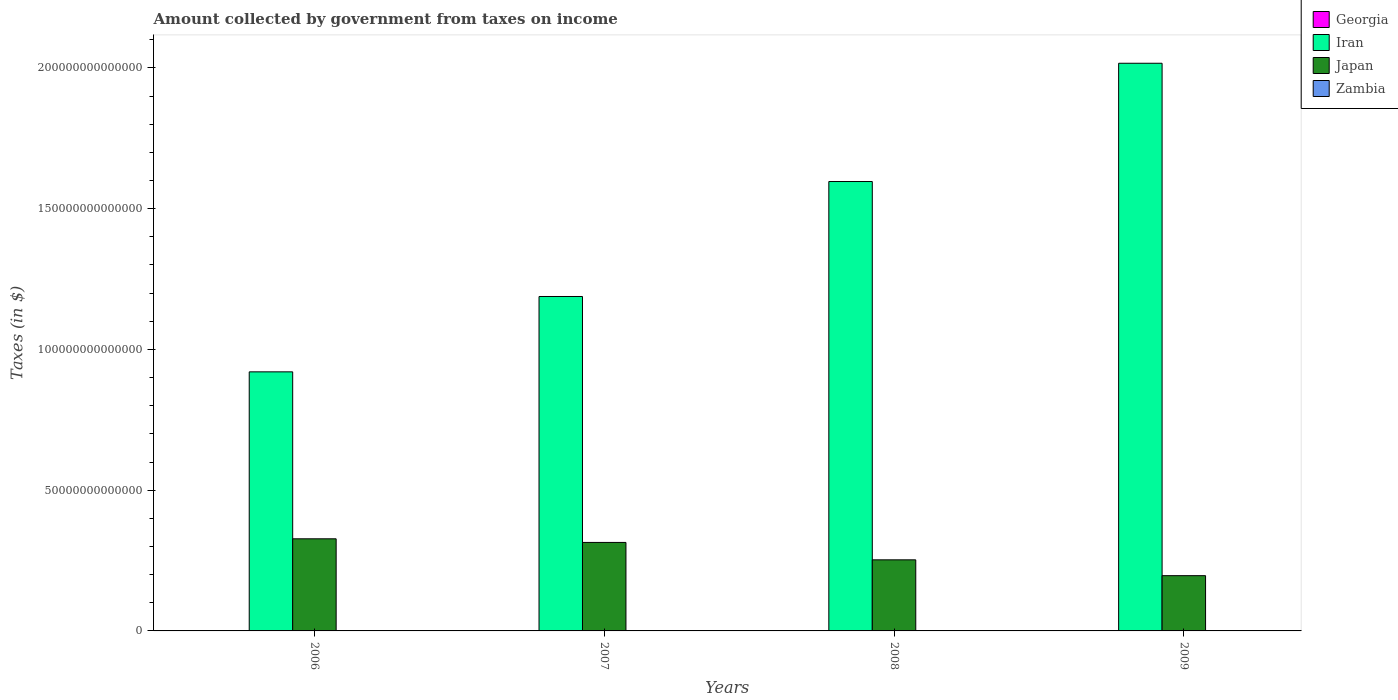Are the number of bars on each tick of the X-axis equal?
Offer a terse response. Yes. How many bars are there on the 1st tick from the left?
Your answer should be compact. 4. How many bars are there on the 1st tick from the right?
Your response must be concise. 4. What is the amount collected by government from taxes on income in Japan in 2008?
Your answer should be very brief. 2.53e+13. Across all years, what is the maximum amount collected by government from taxes on income in Japan?
Ensure brevity in your answer.  3.27e+13. Across all years, what is the minimum amount collected by government from taxes on income in Iran?
Ensure brevity in your answer.  9.20e+13. In which year was the amount collected by government from taxes on income in Georgia maximum?
Make the answer very short. 2008. In which year was the amount collected by government from taxes on income in Georgia minimum?
Your response must be concise. 2006. What is the total amount collected by government from taxes on income in Zambia in the graph?
Ensure brevity in your answer.  1.52e+1. What is the difference between the amount collected by government from taxes on income in Iran in 2006 and that in 2009?
Provide a succinct answer. -1.10e+14. What is the difference between the amount collected by government from taxes on income in Georgia in 2008 and the amount collected by government from taxes on income in Japan in 2009?
Ensure brevity in your answer.  -1.96e+13. What is the average amount collected by government from taxes on income in Iran per year?
Offer a terse response. 1.43e+14. In the year 2006, what is the difference between the amount collected by government from taxes on income in Iran and amount collected by government from taxes on income in Zambia?
Your answer should be compact. 9.20e+13. In how many years, is the amount collected by government from taxes on income in Iran greater than 130000000000000 $?
Keep it short and to the point. 2. What is the ratio of the amount collected by government from taxes on income in Japan in 2008 to that in 2009?
Your response must be concise. 1.29. Is the amount collected by government from taxes on income in Japan in 2007 less than that in 2009?
Your response must be concise. No. Is the difference between the amount collected by government from taxes on income in Iran in 2006 and 2008 greater than the difference between the amount collected by government from taxes on income in Zambia in 2006 and 2008?
Keep it short and to the point. No. What is the difference between the highest and the second highest amount collected by government from taxes on income in Georgia?
Provide a succinct answer. 2.40e+08. What is the difference between the highest and the lowest amount collected by government from taxes on income in Zambia?
Make the answer very short. 1.91e+09. In how many years, is the amount collected by government from taxes on income in Japan greater than the average amount collected by government from taxes on income in Japan taken over all years?
Your answer should be compact. 2. What does the 1st bar from the left in 2006 represents?
Offer a terse response. Georgia. What does the 3rd bar from the right in 2009 represents?
Provide a short and direct response. Iran. How many bars are there?
Give a very brief answer. 16. Are all the bars in the graph horizontal?
Provide a succinct answer. No. What is the difference between two consecutive major ticks on the Y-axis?
Offer a very short reply. 5.00e+13. Does the graph contain grids?
Your response must be concise. No. Where does the legend appear in the graph?
Provide a succinct answer. Top right. How are the legend labels stacked?
Offer a very short reply. Vertical. What is the title of the graph?
Give a very brief answer. Amount collected by government from taxes on income. Does "Tuvalu" appear as one of the legend labels in the graph?
Ensure brevity in your answer.  No. What is the label or title of the X-axis?
Give a very brief answer. Years. What is the label or title of the Y-axis?
Offer a terse response. Taxes (in $). What is the Taxes (in $) in Georgia in 2006?
Offer a terse response. 3.25e+08. What is the Taxes (in $) of Iran in 2006?
Make the answer very short. 9.20e+13. What is the Taxes (in $) in Japan in 2006?
Provide a succinct answer. 3.27e+13. What is the Taxes (in $) of Zambia in 2006?
Make the answer very short. 2.88e+09. What is the Taxes (in $) of Georgia in 2007?
Keep it short and to the point. 5.33e+08. What is the Taxes (in $) in Iran in 2007?
Offer a very short reply. 1.19e+14. What is the Taxes (in $) of Japan in 2007?
Offer a terse response. 3.14e+13. What is the Taxes (in $) of Zambia in 2007?
Provide a succinct answer. 3.34e+09. What is the Taxes (in $) of Georgia in 2008?
Provide a succinct answer. 1.81e+09. What is the Taxes (in $) of Iran in 2008?
Provide a succinct answer. 1.60e+14. What is the Taxes (in $) in Japan in 2008?
Make the answer very short. 2.53e+13. What is the Taxes (in $) of Zambia in 2008?
Offer a very short reply. 4.22e+09. What is the Taxes (in $) of Georgia in 2009?
Give a very brief answer. 1.57e+09. What is the Taxes (in $) in Iran in 2009?
Your response must be concise. 2.02e+14. What is the Taxes (in $) in Japan in 2009?
Provide a short and direct response. 1.96e+13. What is the Taxes (in $) of Zambia in 2009?
Provide a short and direct response. 4.80e+09. Across all years, what is the maximum Taxes (in $) of Georgia?
Offer a very short reply. 1.81e+09. Across all years, what is the maximum Taxes (in $) of Iran?
Your answer should be compact. 2.02e+14. Across all years, what is the maximum Taxes (in $) of Japan?
Give a very brief answer. 3.27e+13. Across all years, what is the maximum Taxes (in $) of Zambia?
Provide a succinct answer. 4.80e+09. Across all years, what is the minimum Taxes (in $) of Georgia?
Ensure brevity in your answer.  3.25e+08. Across all years, what is the minimum Taxes (in $) in Iran?
Your answer should be compact. 9.20e+13. Across all years, what is the minimum Taxes (in $) of Japan?
Your response must be concise. 1.96e+13. Across all years, what is the minimum Taxes (in $) in Zambia?
Offer a very short reply. 2.88e+09. What is the total Taxes (in $) in Georgia in the graph?
Keep it short and to the point. 4.24e+09. What is the total Taxes (in $) of Iran in the graph?
Your response must be concise. 5.72e+14. What is the total Taxes (in $) of Japan in the graph?
Offer a very short reply. 1.09e+14. What is the total Taxes (in $) of Zambia in the graph?
Provide a short and direct response. 1.52e+1. What is the difference between the Taxes (in $) in Georgia in 2006 and that in 2007?
Provide a succinct answer. -2.08e+08. What is the difference between the Taxes (in $) of Iran in 2006 and that in 2007?
Make the answer very short. -2.68e+13. What is the difference between the Taxes (in $) in Japan in 2006 and that in 2007?
Ensure brevity in your answer.  1.29e+12. What is the difference between the Taxes (in $) of Zambia in 2006 and that in 2007?
Provide a short and direct response. -4.56e+08. What is the difference between the Taxes (in $) of Georgia in 2006 and that in 2008?
Your response must be concise. -1.49e+09. What is the difference between the Taxes (in $) in Iran in 2006 and that in 2008?
Your answer should be compact. -6.76e+13. What is the difference between the Taxes (in $) of Japan in 2006 and that in 2008?
Keep it short and to the point. 7.47e+12. What is the difference between the Taxes (in $) of Zambia in 2006 and that in 2008?
Offer a terse response. -1.34e+09. What is the difference between the Taxes (in $) of Georgia in 2006 and that in 2009?
Give a very brief answer. -1.25e+09. What is the difference between the Taxes (in $) in Iran in 2006 and that in 2009?
Your answer should be very brief. -1.10e+14. What is the difference between the Taxes (in $) in Japan in 2006 and that in 2009?
Your answer should be compact. 1.31e+13. What is the difference between the Taxes (in $) of Zambia in 2006 and that in 2009?
Your answer should be compact. -1.91e+09. What is the difference between the Taxes (in $) of Georgia in 2007 and that in 2008?
Your answer should be compact. -1.28e+09. What is the difference between the Taxes (in $) in Iran in 2007 and that in 2008?
Your answer should be compact. -4.08e+13. What is the difference between the Taxes (in $) in Japan in 2007 and that in 2008?
Make the answer very short. 6.18e+12. What is the difference between the Taxes (in $) in Zambia in 2007 and that in 2008?
Offer a terse response. -8.81e+08. What is the difference between the Taxes (in $) in Georgia in 2007 and that in 2009?
Give a very brief answer. -1.04e+09. What is the difference between the Taxes (in $) in Iran in 2007 and that in 2009?
Ensure brevity in your answer.  -8.29e+13. What is the difference between the Taxes (in $) of Japan in 2007 and that in 2009?
Ensure brevity in your answer.  1.18e+13. What is the difference between the Taxes (in $) in Zambia in 2007 and that in 2009?
Ensure brevity in your answer.  -1.46e+09. What is the difference between the Taxes (in $) of Georgia in 2008 and that in 2009?
Offer a terse response. 2.40e+08. What is the difference between the Taxes (in $) in Iran in 2008 and that in 2009?
Provide a short and direct response. -4.20e+13. What is the difference between the Taxes (in $) of Japan in 2008 and that in 2009?
Offer a very short reply. 5.62e+12. What is the difference between the Taxes (in $) in Zambia in 2008 and that in 2009?
Keep it short and to the point. -5.77e+08. What is the difference between the Taxes (in $) of Georgia in 2006 and the Taxes (in $) of Iran in 2007?
Give a very brief answer. -1.19e+14. What is the difference between the Taxes (in $) of Georgia in 2006 and the Taxes (in $) of Japan in 2007?
Your answer should be very brief. -3.14e+13. What is the difference between the Taxes (in $) in Georgia in 2006 and the Taxes (in $) in Zambia in 2007?
Your response must be concise. -3.01e+09. What is the difference between the Taxes (in $) in Iran in 2006 and the Taxes (in $) in Japan in 2007?
Keep it short and to the point. 6.06e+13. What is the difference between the Taxes (in $) in Iran in 2006 and the Taxes (in $) in Zambia in 2007?
Offer a very short reply. 9.20e+13. What is the difference between the Taxes (in $) of Japan in 2006 and the Taxes (in $) of Zambia in 2007?
Provide a succinct answer. 3.27e+13. What is the difference between the Taxes (in $) of Georgia in 2006 and the Taxes (in $) of Iran in 2008?
Your answer should be very brief. -1.60e+14. What is the difference between the Taxes (in $) in Georgia in 2006 and the Taxes (in $) in Japan in 2008?
Offer a terse response. -2.53e+13. What is the difference between the Taxes (in $) in Georgia in 2006 and the Taxes (in $) in Zambia in 2008?
Make the answer very short. -3.90e+09. What is the difference between the Taxes (in $) of Iran in 2006 and the Taxes (in $) of Japan in 2008?
Ensure brevity in your answer.  6.68e+13. What is the difference between the Taxes (in $) in Iran in 2006 and the Taxes (in $) in Zambia in 2008?
Provide a short and direct response. 9.20e+13. What is the difference between the Taxes (in $) of Japan in 2006 and the Taxes (in $) of Zambia in 2008?
Offer a terse response. 3.27e+13. What is the difference between the Taxes (in $) in Georgia in 2006 and the Taxes (in $) in Iran in 2009?
Provide a succinct answer. -2.02e+14. What is the difference between the Taxes (in $) in Georgia in 2006 and the Taxes (in $) in Japan in 2009?
Your answer should be compact. -1.96e+13. What is the difference between the Taxes (in $) of Georgia in 2006 and the Taxes (in $) of Zambia in 2009?
Offer a terse response. -4.47e+09. What is the difference between the Taxes (in $) of Iran in 2006 and the Taxes (in $) of Japan in 2009?
Your answer should be very brief. 7.24e+13. What is the difference between the Taxes (in $) in Iran in 2006 and the Taxes (in $) in Zambia in 2009?
Keep it short and to the point. 9.20e+13. What is the difference between the Taxes (in $) in Japan in 2006 and the Taxes (in $) in Zambia in 2009?
Keep it short and to the point. 3.27e+13. What is the difference between the Taxes (in $) of Georgia in 2007 and the Taxes (in $) of Iran in 2008?
Provide a short and direct response. -1.60e+14. What is the difference between the Taxes (in $) of Georgia in 2007 and the Taxes (in $) of Japan in 2008?
Ensure brevity in your answer.  -2.53e+13. What is the difference between the Taxes (in $) of Georgia in 2007 and the Taxes (in $) of Zambia in 2008?
Provide a short and direct response. -3.69e+09. What is the difference between the Taxes (in $) of Iran in 2007 and the Taxes (in $) of Japan in 2008?
Offer a very short reply. 9.36e+13. What is the difference between the Taxes (in $) in Iran in 2007 and the Taxes (in $) in Zambia in 2008?
Keep it short and to the point. 1.19e+14. What is the difference between the Taxes (in $) of Japan in 2007 and the Taxes (in $) of Zambia in 2008?
Ensure brevity in your answer.  3.14e+13. What is the difference between the Taxes (in $) in Georgia in 2007 and the Taxes (in $) in Iran in 2009?
Give a very brief answer. -2.02e+14. What is the difference between the Taxes (in $) in Georgia in 2007 and the Taxes (in $) in Japan in 2009?
Offer a very short reply. -1.96e+13. What is the difference between the Taxes (in $) in Georgia in 2007 and the Taxes (in $) in Zambia in 2009?
Offer a very short reply. -4.26e+09. What is the difference between the Taxes (in $) in Iran in 2007 and the Taxes (in $) in Japan in 2009?
Your response must be concise. 9.92e+13. What is the difference between the Taxes (in $) of Iran in 2007 and the Taxes (in $) of Zambia in 2009?
Offer a very short reply. 1.19e+14. What is the difference between the Taxes (in $) of Japan in 2007 and the Taxes (in $) of Zambia in 2009?
Your answer should be very brief. 3.14e+13. What is the difference between the Taxes (in $) of Georgia in 2008 and the Taxes (in $) of Iran in 2009?
Give a very brief answer. -2.02e+14. What is the difference between the Taxes (in $) of Georgia in 2008 and the Taxes (in $) of Japan in 2009?
Your response must be concise. -1.96e+13. What is the difference between the Taxes (in $) in Georgia in 2008 and the Taxes (in $) in Zambia in 2009?
Offer a very short reply. -2.99e+09. What is the difference between the Taxes (in $) of Iran in 2008 and the Taxes (in $) of Japan in 2009?
Provide a short and direct response. 1.40e+14. What is the difference between the Taxes (in $) of Iran in 2008 and the Taxes (in $) of Zambia in 2009?
Your answer should be very brief. 1.60e+14. What is the difference between the Taxes (in $) of Japan in 2008 and the Taxes (in $) of Zambia in 2009?
Make the answer very short. 2.53e+13. What is the average Taxes (in $) in Georgia per year?
Give a very brief answer. 1.06e+09. What is the average Taxes (in $) in Iran per year?
Keep it short and to the point. 1.43e+14. What is the average Taxes (in $) of Japan per year?
Provide a succinct answer. 2.73e+13. What is the average Taxes (in $) of Zambia per year?
Keep it short and to the point. 3.81e+09. In the year 2006, what is the difference between the Taxes (in $) in Georgia and Taxes (in $) in Iran?
Your answer should be very brief. -9.20e+13. In the year 2006, what is the difference between the Taxes (in $) of Georgia and Taxes (in $) of Japan?
Give a very brief answer. -3.27e+13. In the year 2006, what is the difference between the Taxes (in $) of Georgia and Taxes (in $) of Zambia?
Keep it short and to the point. -2.56e+09. In the year 2006, what is the difference between the Taxes (in $) in Iran and Taxes (in $) in Japan?
Offer a terse response. 5.93e+13. In the year 2006, what is the difference between the Taxes (in $) of Iran and Taxes (in $) of Zambia?
Give a very brief answer. 9.20e+13. In the year 2006, what is the difference between the Taxes (in $) in Japan and Taxes (in $) in Zambia?
Give a very brief answer. 3.27e+13. In the year 2007, what is the difference between the Taxes (in $) in Georgia and Taxes (in $) in Iran?
Offer a terse response. -1.19e+14. In the year 2007, what is the difference between the Taxes (in $) in Georgia and Taxes (in $) in Japan?
Ensure brevity in your answer.  -3.14e+13. In the year 2007, what is the difference between the Taxes (in $) of Georgia and Taxes (in $) of Zambia?
Give a very brief answer. -2.81e+09. In the year 2007, what is the difference between the Taxes (in $) of Iran and Taxes (in $) of Japan?
Provide a succinct answer. 8.74e+13. In the year 2007, what is the difference between the Taxes (in $) of Iran and Taxes (in $) of Zambia?
Keep it short and to the point. 1.19e+14. In the year 2007, what is the difference between the Taxes (in $) of Japan and Taxes (in $) of Zambia?
Offer a terse response. 3.14e+13. In the year 2008, what is the difference between the Taxes (in $) of Georgia and Taxes (in $) of Iran?
Make the answer very short. -1.60e+14. In the year 2008, what is the difference between the Taxes (in $) in Georgia and Taxes (in $) in Japan?
Provide a succinct answer. -2.53e+13. In the year 2008, what is the difference between the Taxes (in $) of Georgia and Taxes (in $) of Zambia?
Your response must be concise. -2.41e+09. In the year 2008, what is the difference between the Taxes (in $) in Iran and Taxes (in $) in Japan?
Give a very brief answer. 1.34e+14. In the year 2008, what is the difference between the Taxes (in $) of Iran and Taxes (in $) of Zambia?
Keep it short and to the point. 1.60e+14. In the year 2008, what is the difference between the Taxes (in $) of Japan and Taxes (in $) of Zambia?
Provide a short and direct response. 2.53e+13. In the year 2009, what is the difference between the Taxes (in $) in Georgia and Taxes (in $) in Iran?
Offer a terse response. -2.02e+14. In the year 2009, what is the difference between the Taxes (in $) of Georgia and Taxes (in $) of Japan?
Make the answer very short. -1.96e+13. In the year 2009, what is the difference between the Taxes (in $) of Georgia and Taxes (in $) of Zambia?
Your answer should be very brief. -3.23e+09. In the year 2009, what is the difference between the Taxes (in $) in Iran and Taxes (in $) in Japan?
Your answer should be very brief. 1.82e+14. In the year 2009, what is the difference between the Taxes (in $) of Iran and Taxes (in $) of Zambia?
Your answer should be compact. 2.02e+14. In the year 2009, what is the difference between the Taxes (in $) in Japan and Taxes (in $) in Zambia?
Provide a succinct answer. 1.96e+13. What is the ratio of the Taxes (in $) of Georgia in 2006 to that in 2007?
Ensure brevity in your answer.  0.61. What is the ratio of the Taxes (in $) of Iran in 2006 to that in 2007?
Ensure brevity in your answer.  0.77. What is the ratio of the Taxes (in $) of Japan in 2006 to that in 2007?
Keep it short and to the point. 1.04. What is the ratio of the Taxes (in $) of Zambia in 2006 to that in 2007?
Give a very brief answer. 0.86. What is the ratio of the Taxes (in $) of Georgia in 2006 to that in 2008?
Your answer should be very brief. 0.18. What is the ratio of the Taxes (in $) of Iran in 2006 to that in 2008?
Offer a very short reply. 0.58. What is the ratio of the Taxes (in $) of Japan in 2006 to that in 2008?
Offer a very short reply. 1.3. What is the ratio of the Taxes (in $) of Zambia in 2006 to that in 2008?
Your answer should be very brief. 0.68. What is the ratio of the Taxes (in $) of Georgia in 2006 to that in 2009?
Your answer should be compact. 0.21. What is the ratio of the Taxes (in $) of Iran in 2006 to that in 2009?
Give a very brief answer. 0.46. What is the ratio of the Taxes (in $) in Japan in 2006 to that in 2009?
Your response must be concise. 1.67. What is the ratio of the Taxes (in $) of Zambia in 2006 to that in 2009?
Make the answer very short. 0.6. What is the ratio of the Taxes (in $) of Georgia in 2007 to that in 2008?
Your answer should be compact. 0.29. What is the ratio of the Taxes (in $) of Iran in 2007 to that in 2008?
Make the answer very short. 0.74. What is the ratio of the Taxes (in $) of Japan in 2007 to that in 2008?
Keep it short and to the point. 1.24. What is the ratio of the Taxes (in $) in Zambia in 2007 to that in 2008?
Ensure brevity in your answer.  0.79. What is the ratio of the Taxes (in $) in Georgia in 2007 to that in 2009?
Your response must be concise. 0.34. What is the ratio of the Taxes (in $) of Iran in 2007 to that in 2009?
Make the answer very short. 0.59. What is the ratio of the Taxes (in $) in Japan in 2007 to that in 2009?
Offer a very short reply. 1.6. What is the ratio of the Taxes (in $) in Zambia in 2007 to that in 2009?
Keep it short and to the point. 0.7. What is the ratio of the Taxes (in $) in Georgia in 2008 to that in 2009?
Provide a short and direct response. 1.15. What is the ratio of the Taxes (in $) in Iran in 2008 to that in 2009?
Give a very brief answer. 0.79. What is the ratio of the Taxes (in $) of Japan in 2008 to that in 2009?
Provide a succinct answer. 1.29. What is the ratio of the Taxes (in $) in Zambia in 2008 to that in 2009?
Provide a succinct answer. 0.88. What is the difference between the highest and the second highest Taxes (in $) in Georgia?
Keep it short and to the point. 2.40e+08. What is the difference between the highest and the second highest Taxes (in $) in Iran?
Provide a succinct answer. 4.20e+13. What is the difference between the highest and the second highest Taxes (in $) of Japan?
Provide a short and direct response. 1.29e+12. What is the difference between the highest and the second highest Taxes (in $) in Zambia?
Offer a terse response. 5.77e+08. What is the difference between the highest and the lowest Taxes (in $) of Georgia?
Your answer should be very brief. 1.49e+09. What is the difference between the highest and the lowest Taxes (in $) of Iran?
Offer a terse response. 1.10e+14. What is the difference between the highest and the lowest Taxes (in $) in Japan?
Offer a very short reply. 1.31e+13. What is the difference between the highest and the lowest Taxes (in $) in Zambia?
Offer a very short reply. 1.91e+09. 